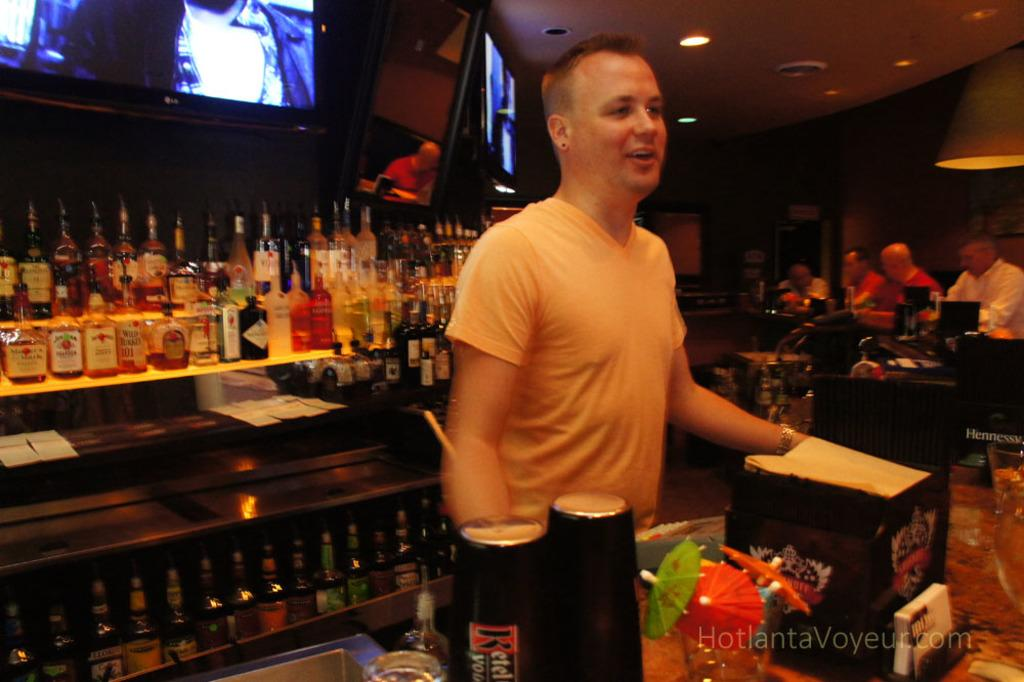<image>
Render a clear and concise summary of the photo. the word Voyeur is under the man that is at the bar 